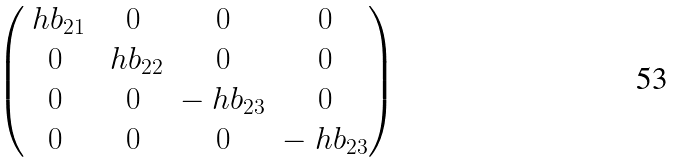<formula> <loc_0><loc_0><loc_500><loc_500>\begin{pmatrix} \ h b _ { 2 1 } & 0 & 0 & 0 \\ 0 & \ h b _ { 2 2 } & 0 & 0 \\ 0 & 0 & - \ h b _ { 2 3 } & 0 \\ 0 & 0 & 0 & - \ h b _ { 2 3 } \end{pmatrix}</formula> 